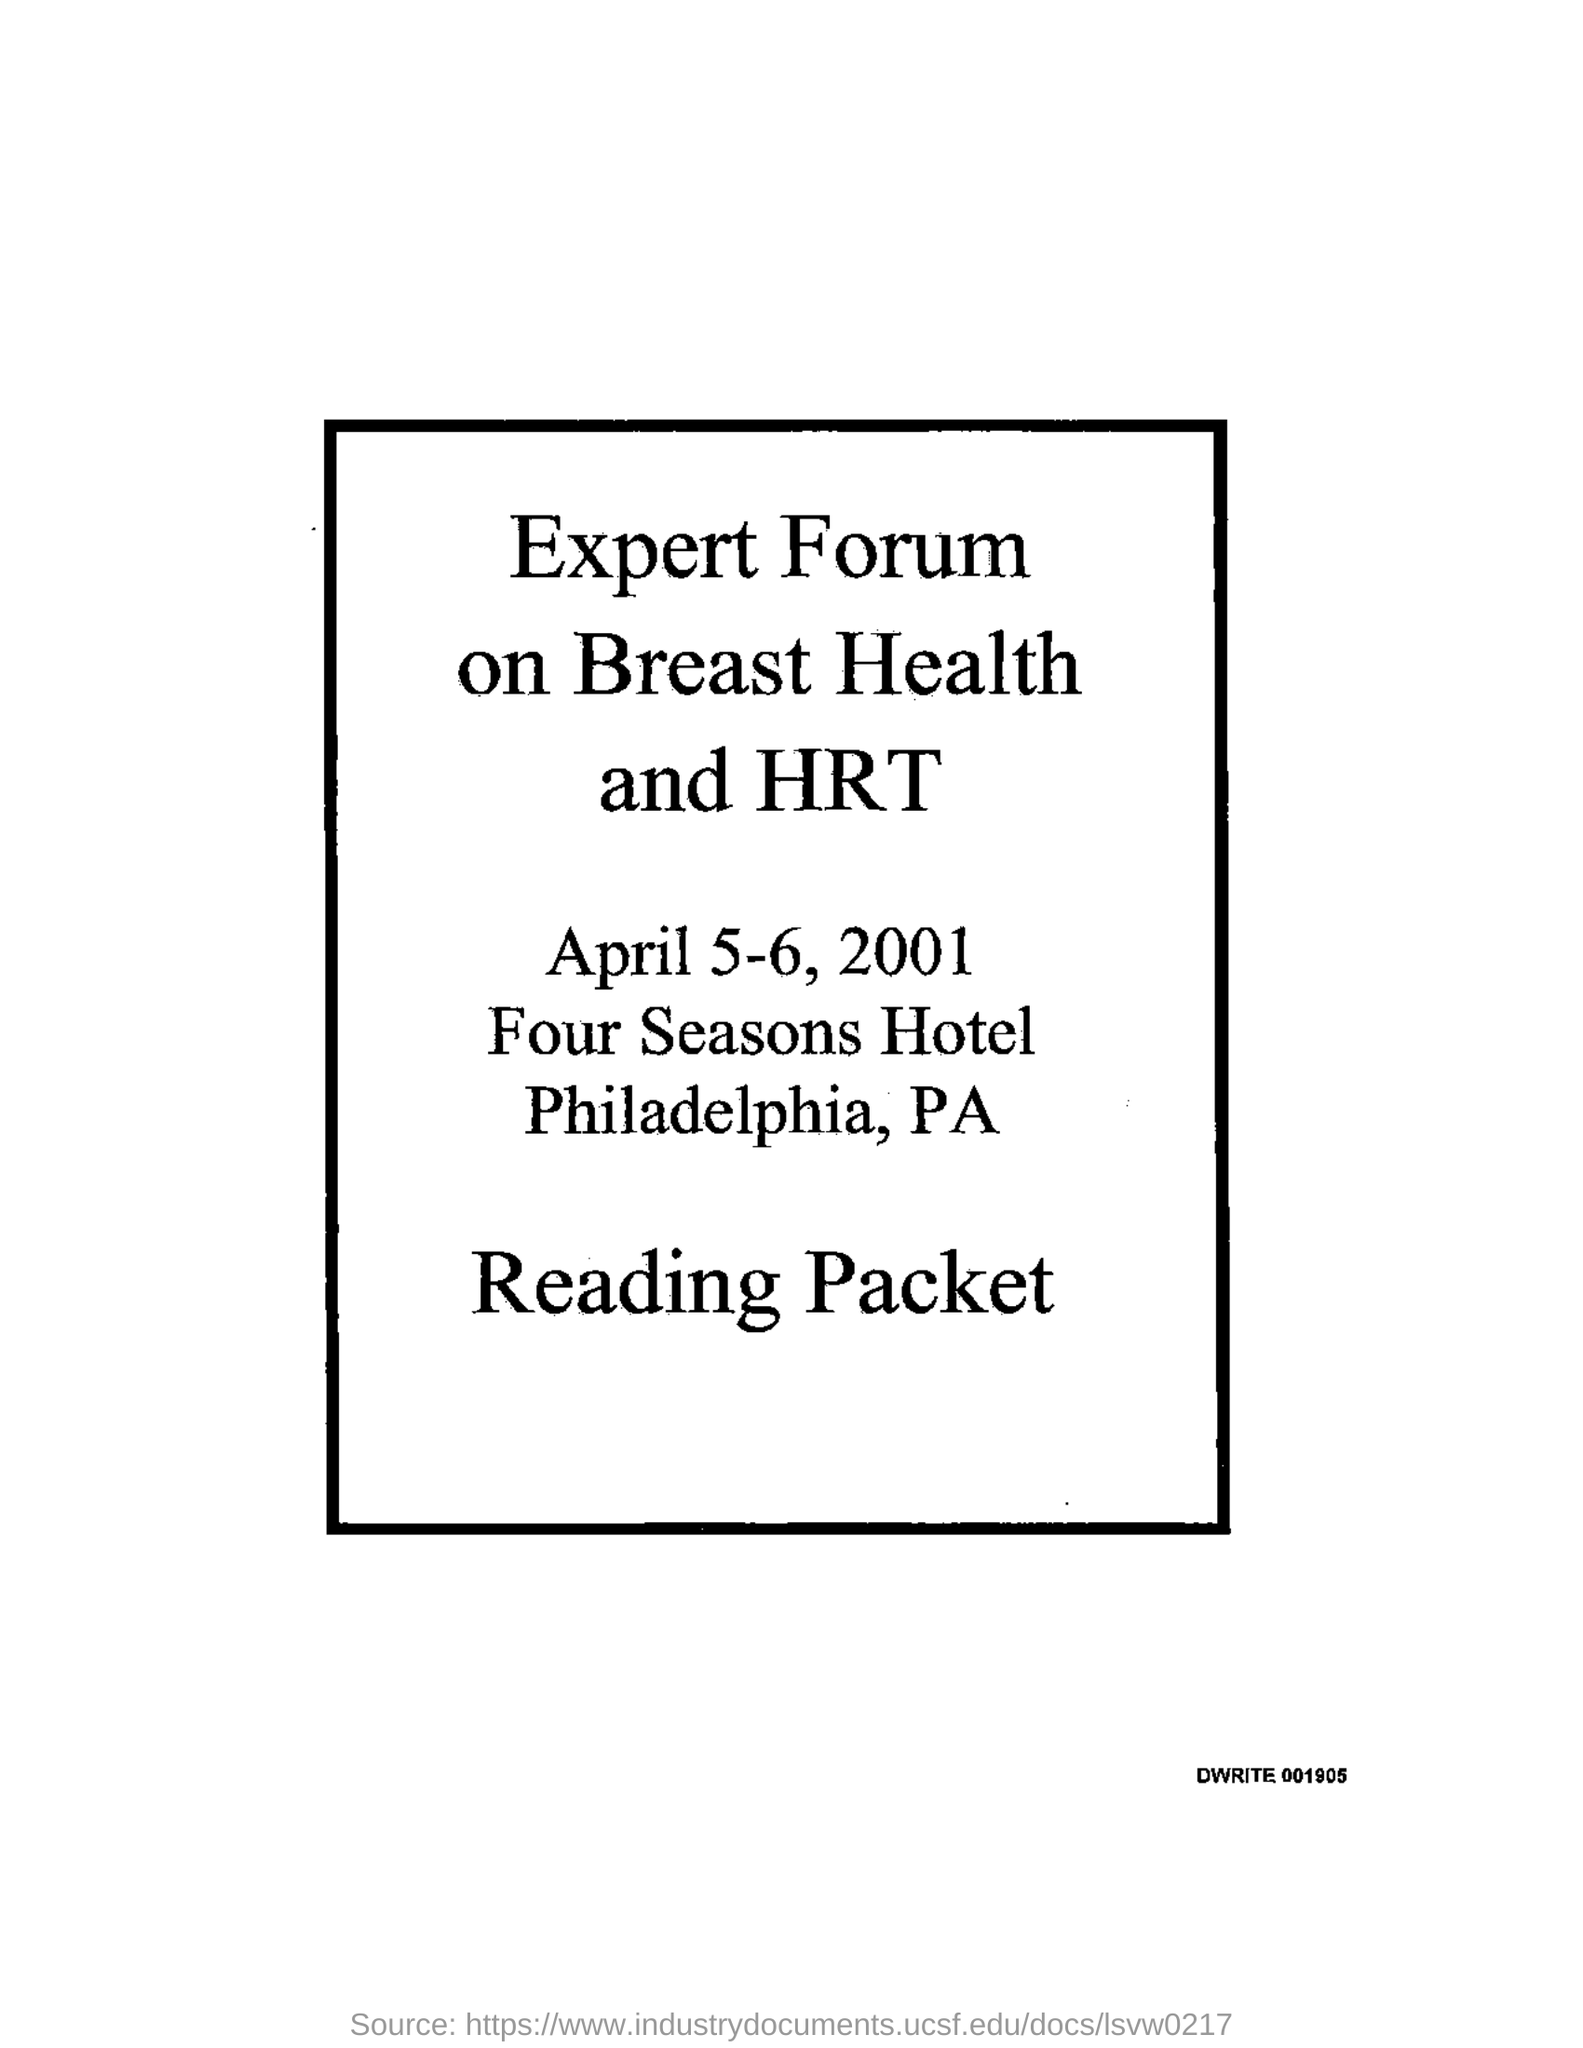When is the Expert Forum on Breast Health and HRT held?
Your response must be concise. April 5-6, 2001. 